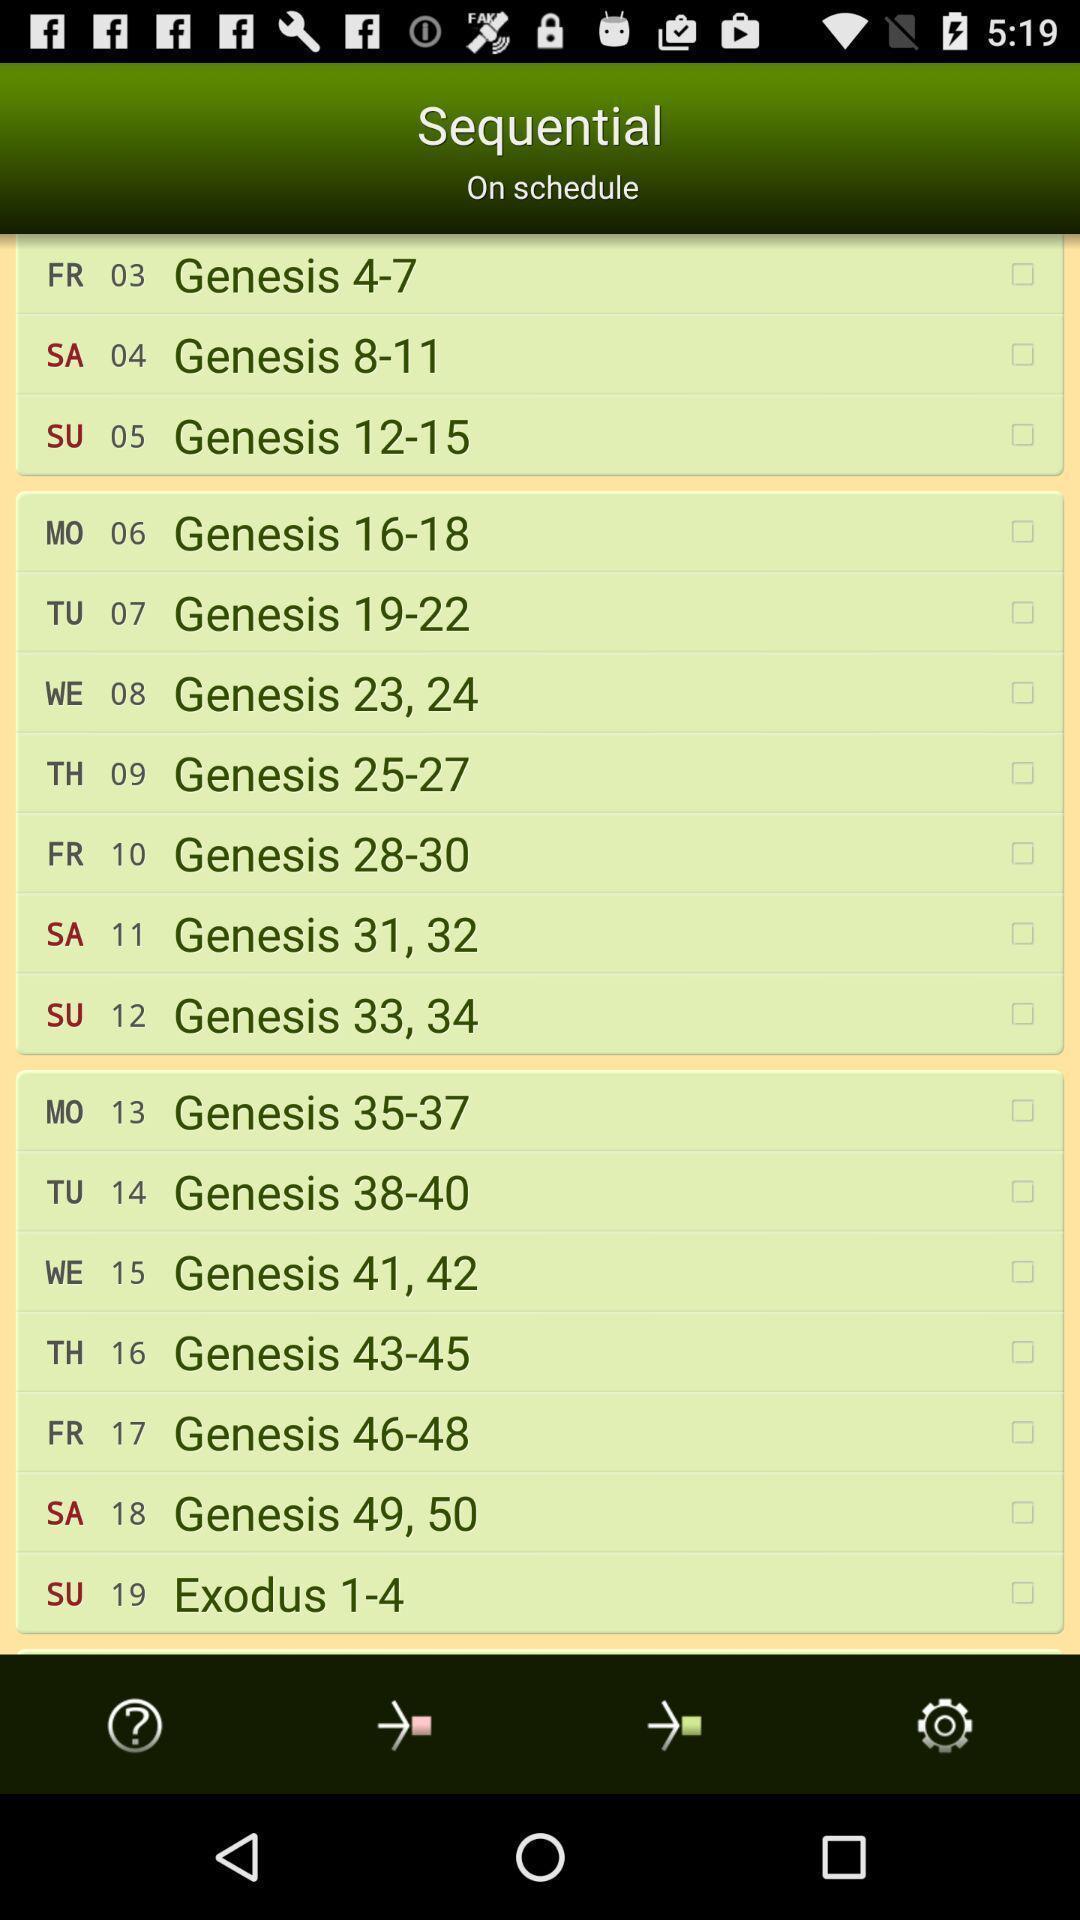Explain what's happening in this screen capture. Page showing information about bible. 